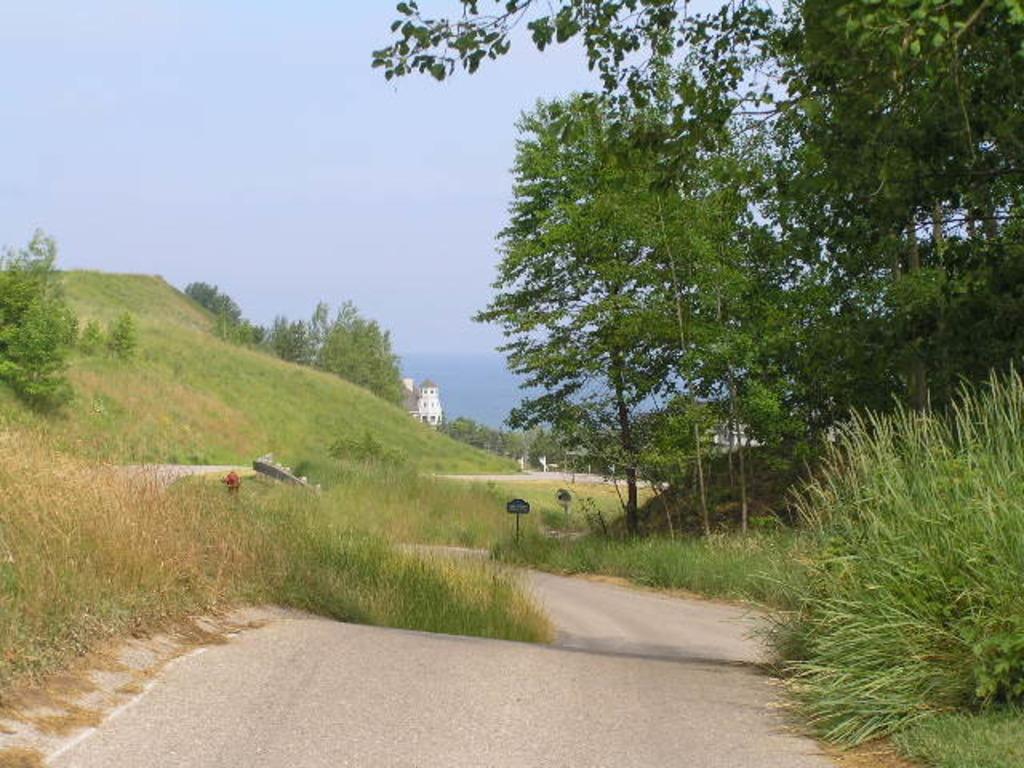In one or two sentences, can you explain what this image depicts? In this picture I can see there is a road and there are trees on right side and there is a mountain at left, it has grass, trees and there is a building in the backdrop, there is an ocean and the sky is clear. 